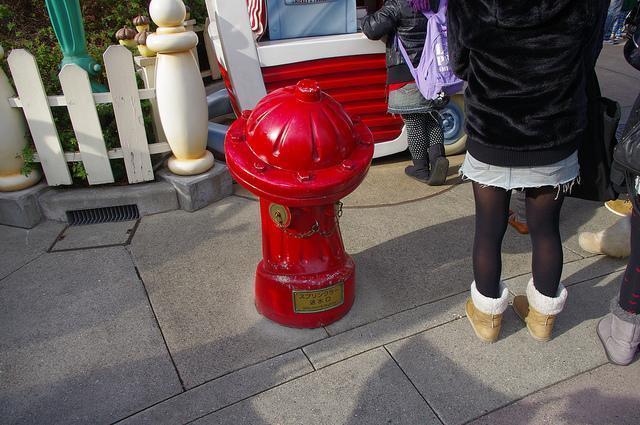How many slats are in the fence?
Give a very brief answer. 3. How many people can be seen?
Give a very brief answer. 3. How many elephants are in this photo?
Give a very brief answer. 0. 